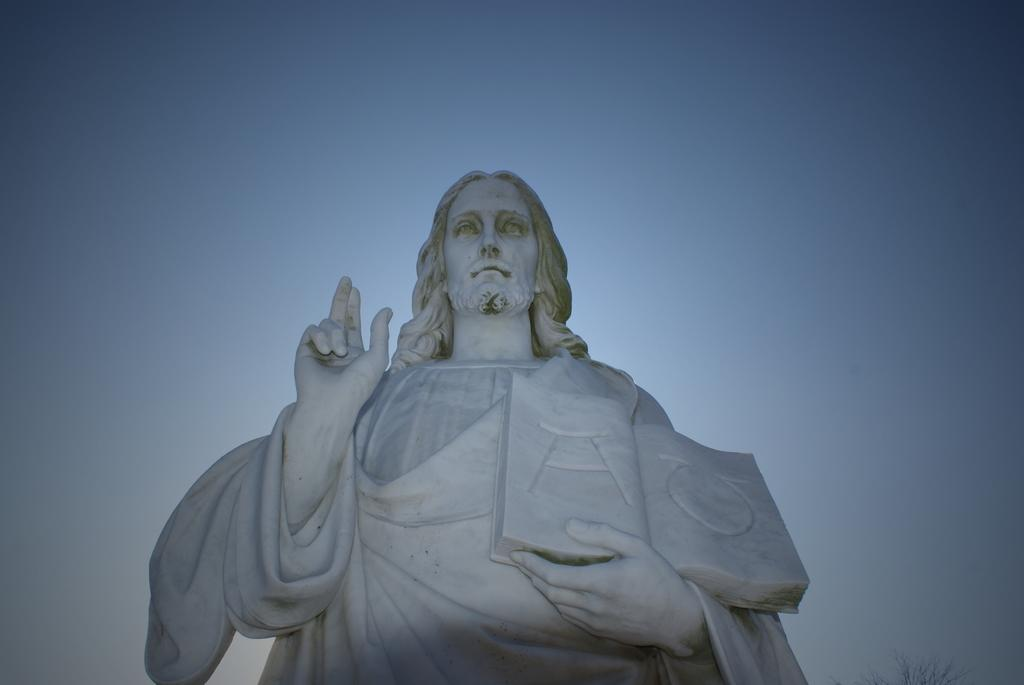What is the main subject of the image? There is a sculpture in the image. Can you tell me how many boats are in the image? There is no boat present in the image; it features a sculpture. What type of sponge is being used to clean the sculpture in the image? There is no sponge or cleaning activity depicted in the image; it only shows a sculpture. 